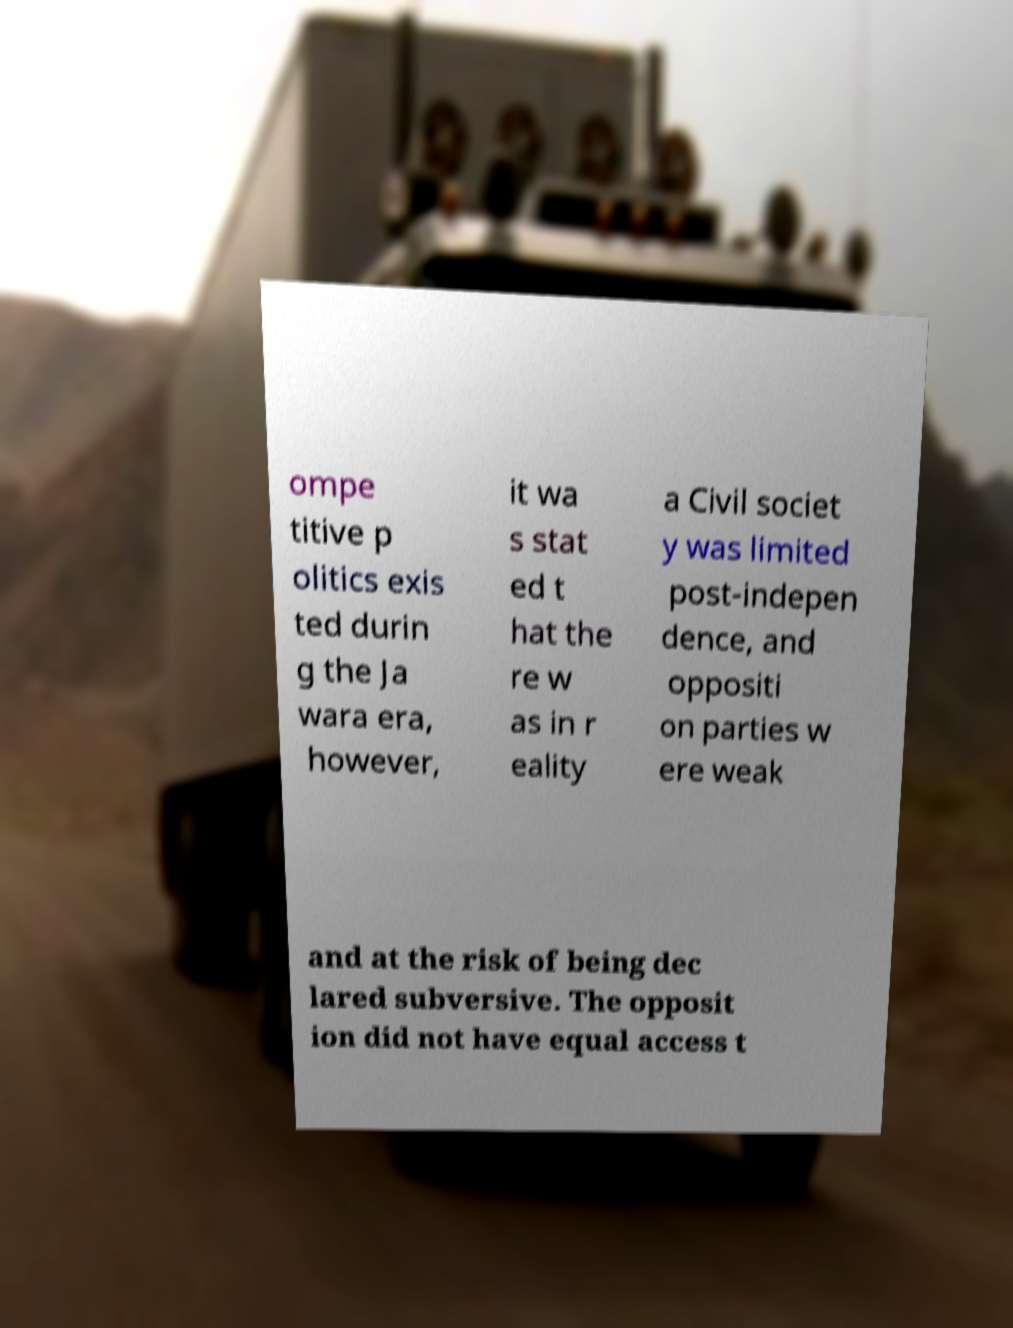Can you accurately transcribe the text from the provided image for me? ompe titive p olitics exis ted durin g the Ja wara era, however, it wa s stat ed t hat the re w as in r eality a Civil societ y was limited post-indepen dence, and oppositi on parties w ere weak and at the risk of being dec lared subversive. The opposit ion did not have equal access t 